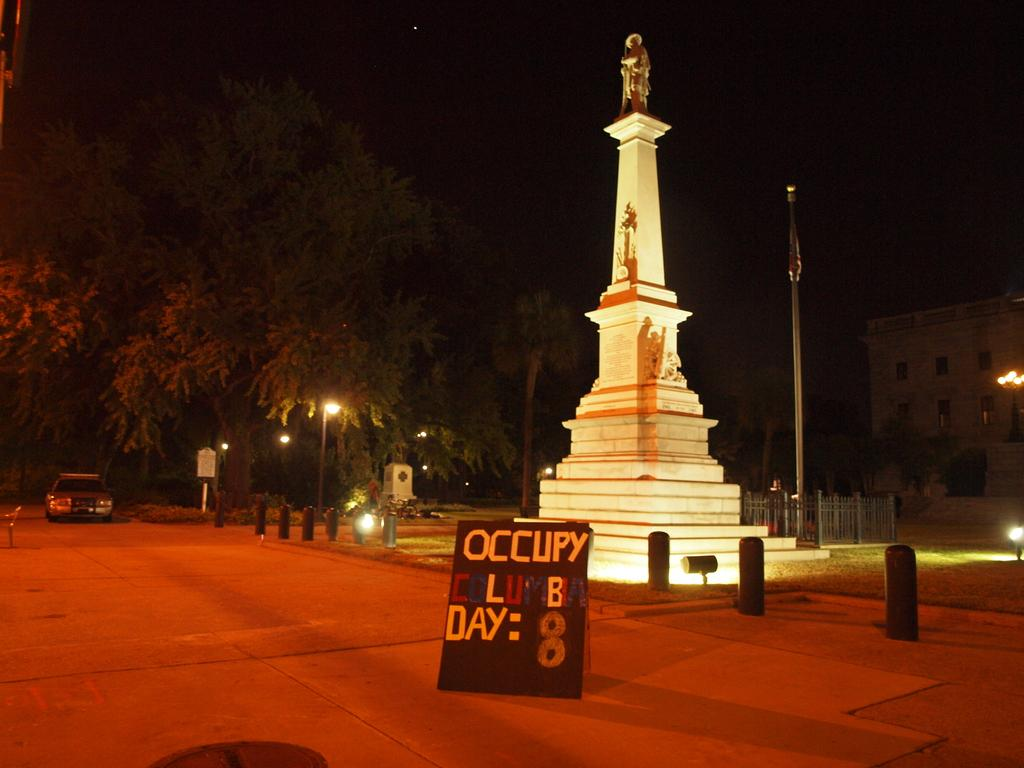<image>
Create a compact narrative representing the image presented. a lit up statue with a sign saying OCCUPY in front 